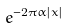<formula> <loc_0><loc_0><loc_500><loc_500>e ^ { - 2 \pi \alpha | x | }</formula> 